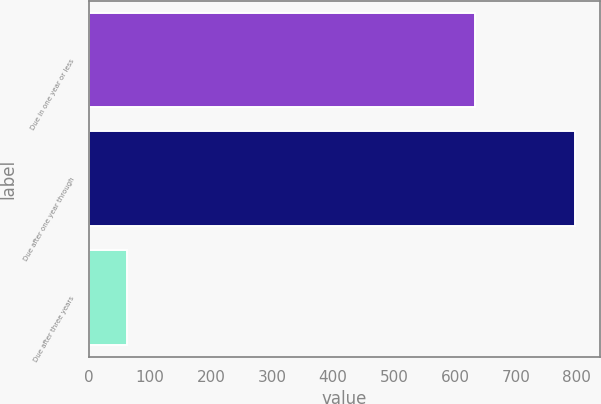Convert chart. <chart><loc_0><loc_0><loc_500><loc_500><bar_chart><fcel>Due in one year or less<fcel>Due after one year through<fcel>Due after three years<nl><fcel>633.6<fcel>797.3<fcel>63.1<nl></chart> 